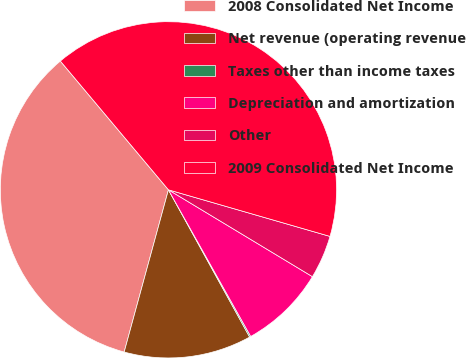Convert chart. <chart><loc_0><loc_0><loc_500><loc_500><pie_chart><fcel>2008 Consolidated Net Income<fcel>Net revenue (operating revenue<fcel>Taxes other than income taxes<fcel>Depreciation and amortization<fcel>Other<fcel>2009 Consolidated Net Income<nl><fcel>34.64%<fcel>12.26%<fcel>0.12%<fcel>8.22%<fcel>4.17%<fcel>40.58%<nl></chart> 